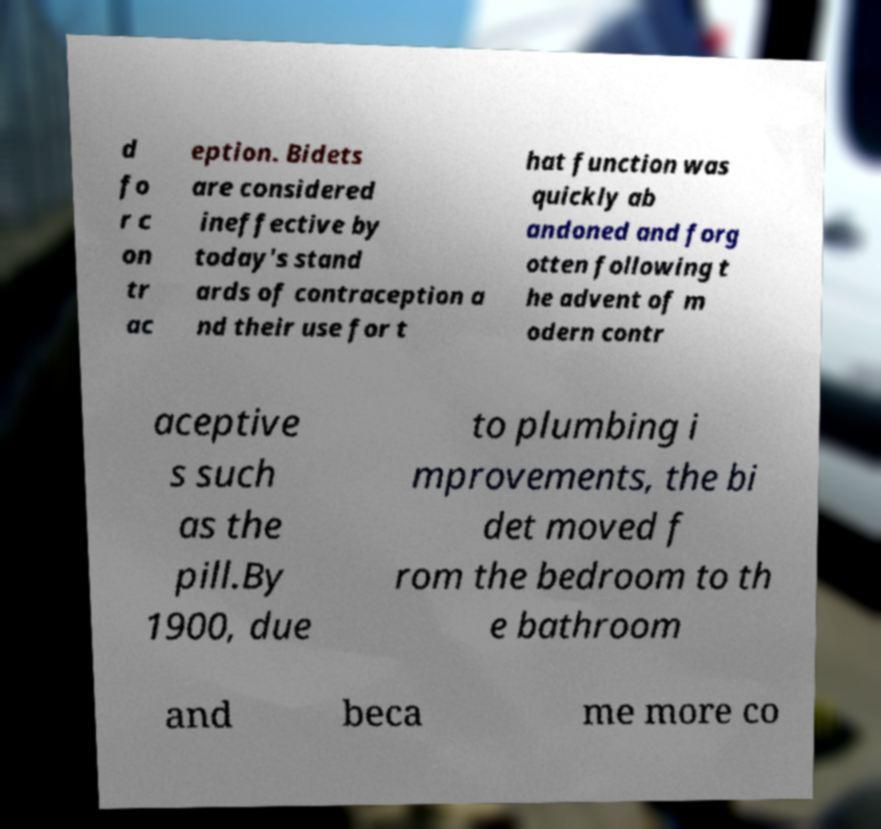Can you read and provide the text displayed in the image?This photo seems to have some interesting text. Can you extract and type it out for me? d fo r c on tr ac eption. Bidets are considered ineffective by today's stand ards of contraception a nd their use for t hat function was quickly ab andoned and forg otten following t he advent of m odern contr aceptive s such as the pill.By 1900, due to plumbing i mprovements, the bi det moved f rom the bedroom to th e bathroom and beca me more co 